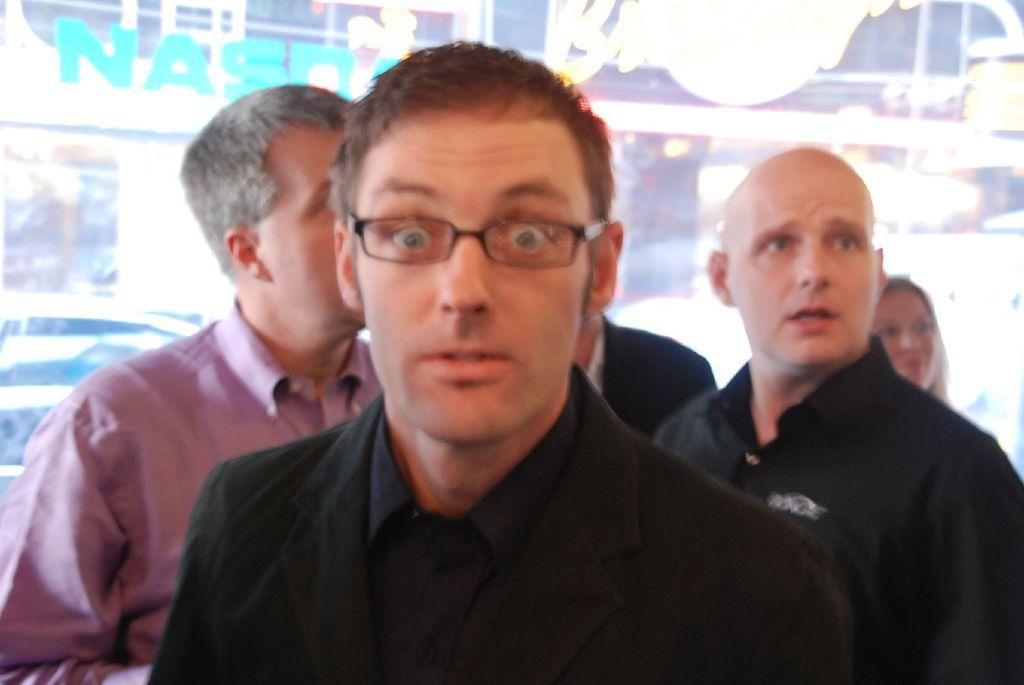Who is the main subject in the image? There is a person in the image. What can be observed about the person's appearance? The person is wearing spectacles. Are there any other people visible in the image? Yes, there are other people visible in the image. What type of fog can be seen in the image? There is no fog present in the image. What is the person in the image paying attention to? The provided facts do not give any information about what the person is paying attention to, so we cannot answer this question definitively. 